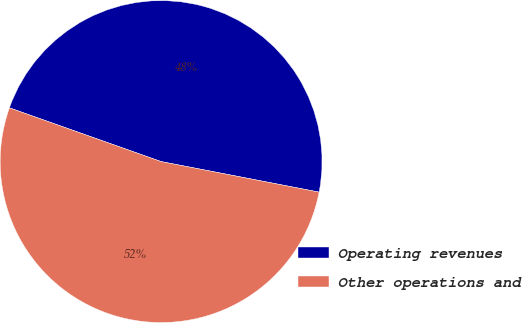<chart> <loc_0><loc_0><loc_500><loc_500><pie_chart><fcel>Operating revenues<fcel>Other operations and<nl><fcel>47.62%<fcel>52.38%<nl></chart> 